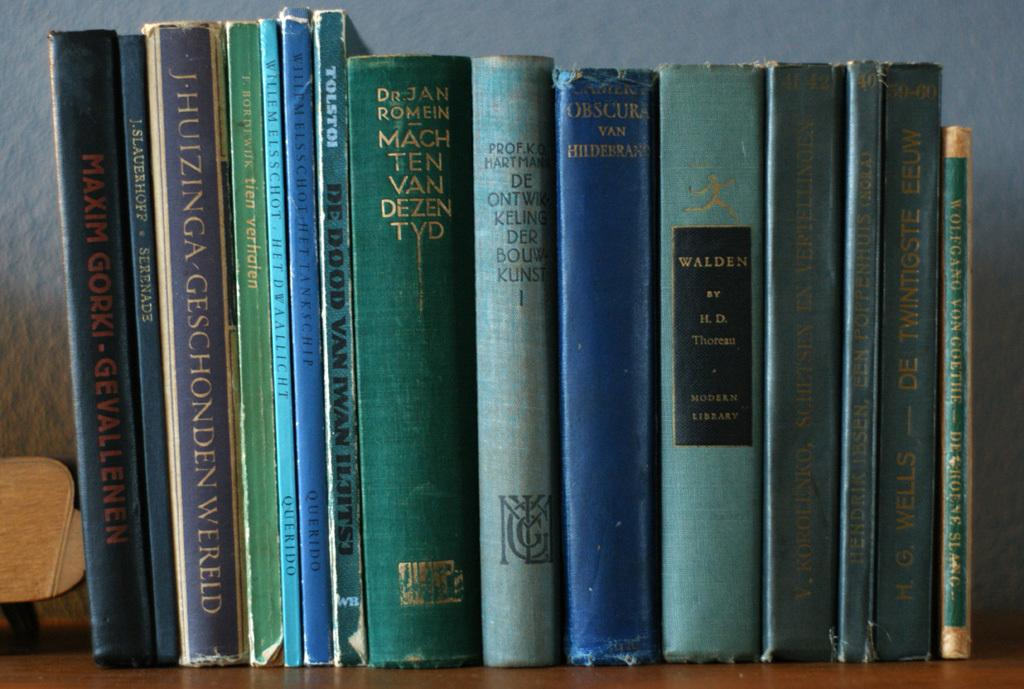<image>
Relay a brief, clear account of the picture shown. Willem Elsschot wrote two of the books displayed on the shelf. 